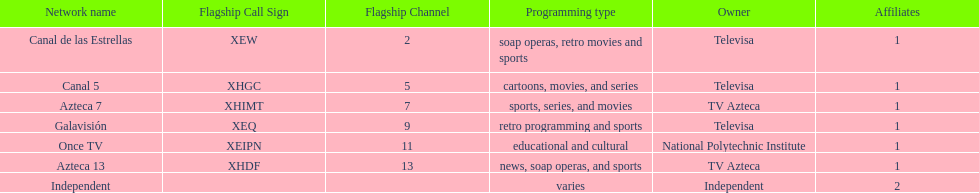What is the total number of affiliates among all the networks? 8. 